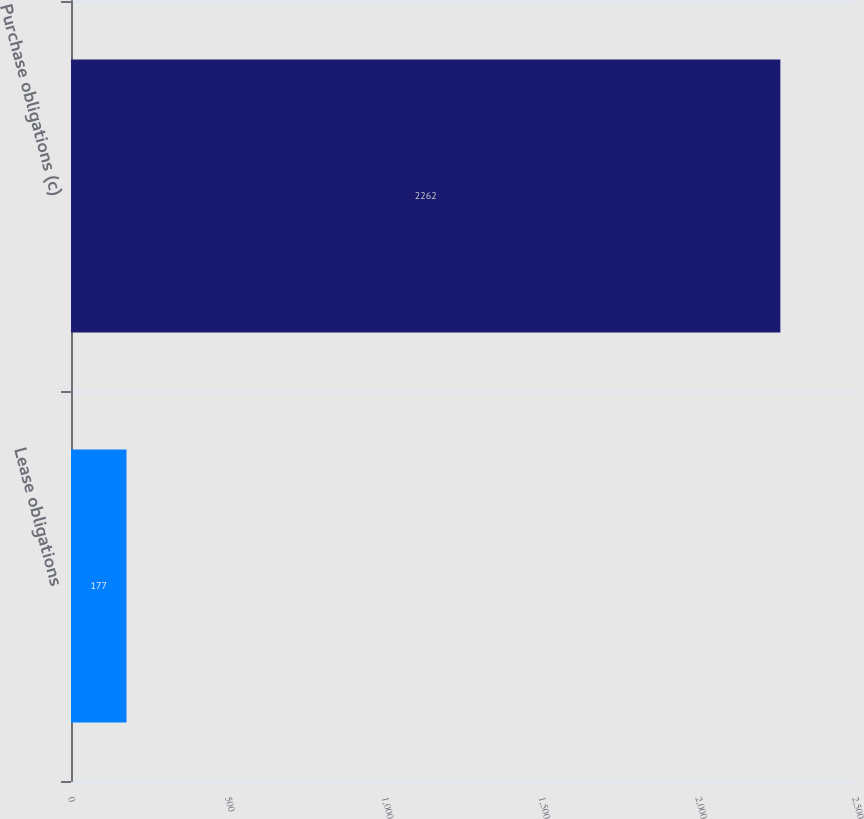Convert chart. <chart><loc_0><loc_0><loc_500><loc_500><bar_chart><fcel>Lease obligations<fcel>Purchase obligations (c)<nl><fcel>177<fcel>2262<nl></chart> 